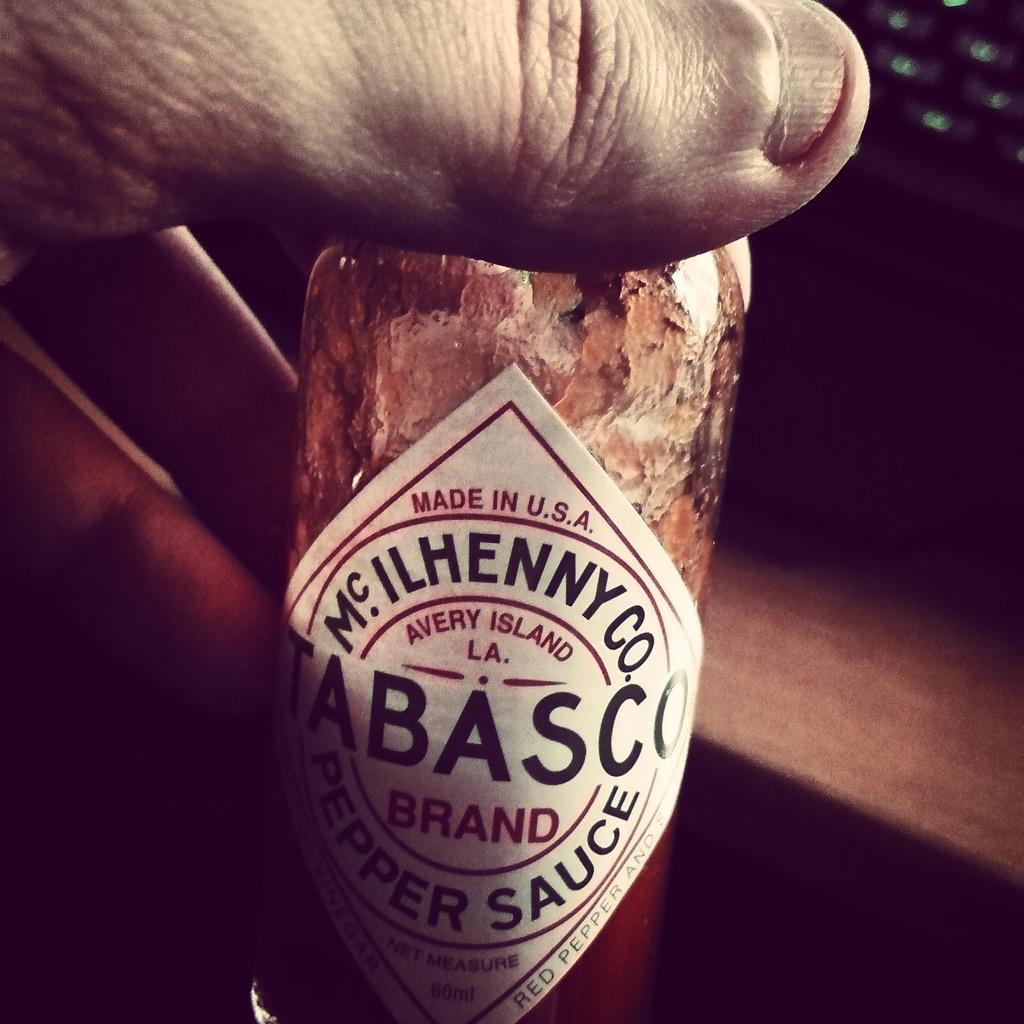What is present in the image? There is a person in the image. What is the person holding in his hand? The person is holding a pepper sauce bottle in his hand. What type of oatmeal is being prepared in the image? There is no oatmeal present in the image; the person is holding a pepper sauce bottle. 